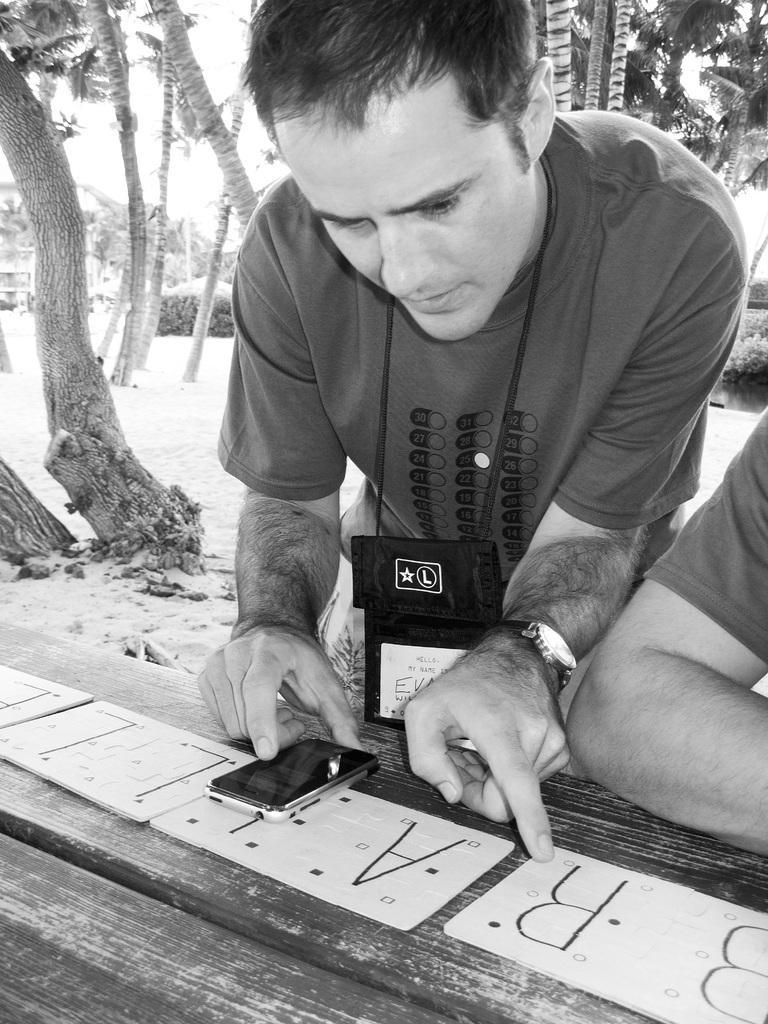Can you describe this image briefly? As we can see in the image in the front there are two people and table. On table there is a mobile phone. In the background there are trees and sky. 